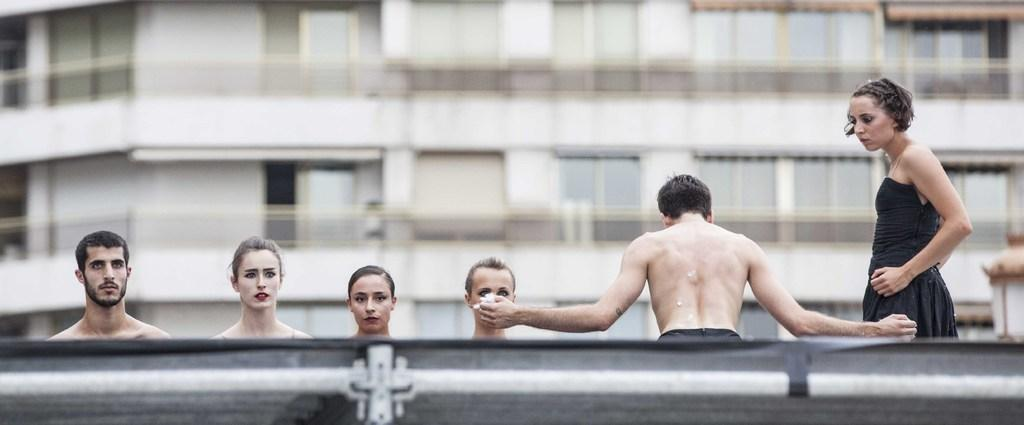What is located at the bottom of the image? There is fencing at the bottom of the image. What can be seen behind the fencing? There are people behind the fencing. How would you describe the background behind the people? The background behind the people is blurred. What type of structures are visible in the background? There are walls, glass windows, and railings visible in the background. How many cars are parked in front of the people in the image? There are no cars visible in the image; it only shows fencing, people, and the background structures. What type of sticks are being used by the crowd in the image? There is no crowd present in the image, and therefore no sticks being used. 